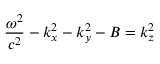<formula> <loc_0><loc_0><loc_500><loc_500>\frac { \omega ^ { 2 } } { c ^ { 2 } } - k _ { x } ^ { 2 } - k _ { y } ^ { 2 } - B = k _ { z } ^ { 2 }</formula> 